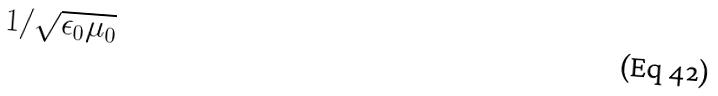Convert formula to latex. <formula><loc_0><loc_0><loc_500><loc_500>1 / \sqrt { \epsilon _ { 0 } \mu _ { 0 } }</formula> 